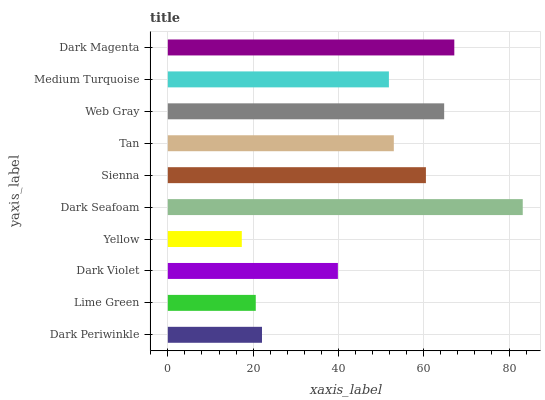Is Yellow the minimum?
Answer yes or no. Yes. Is Dark Seafoam the maximum?
Answer yes or no. Yes. Is Lime Green the minimum?
Answer yes or no. No. Is Lime Green the maximum?
Answer yes or no. No. Is Dark Periwinkle greater than Lime Green?
Answer yes or no. Yes. Is Lime Green less than Dark Periwinkle?
Answer yes or no. Yes. Is Lime Green greater than Dark Periwinkle?
Answer yes or no. No. Is Dark Periwinkle less than Lime Green?
Answer yes or no. No. Is Tan the high median?
Answer yes or no. Yes. Is Medium Turquoise the low median?
Answer yes or no. Yes. Is Dark Seafoam the high median?
Answer yes or no. No. Is Dark Magenta the low median?
Answer yes or no. No. 